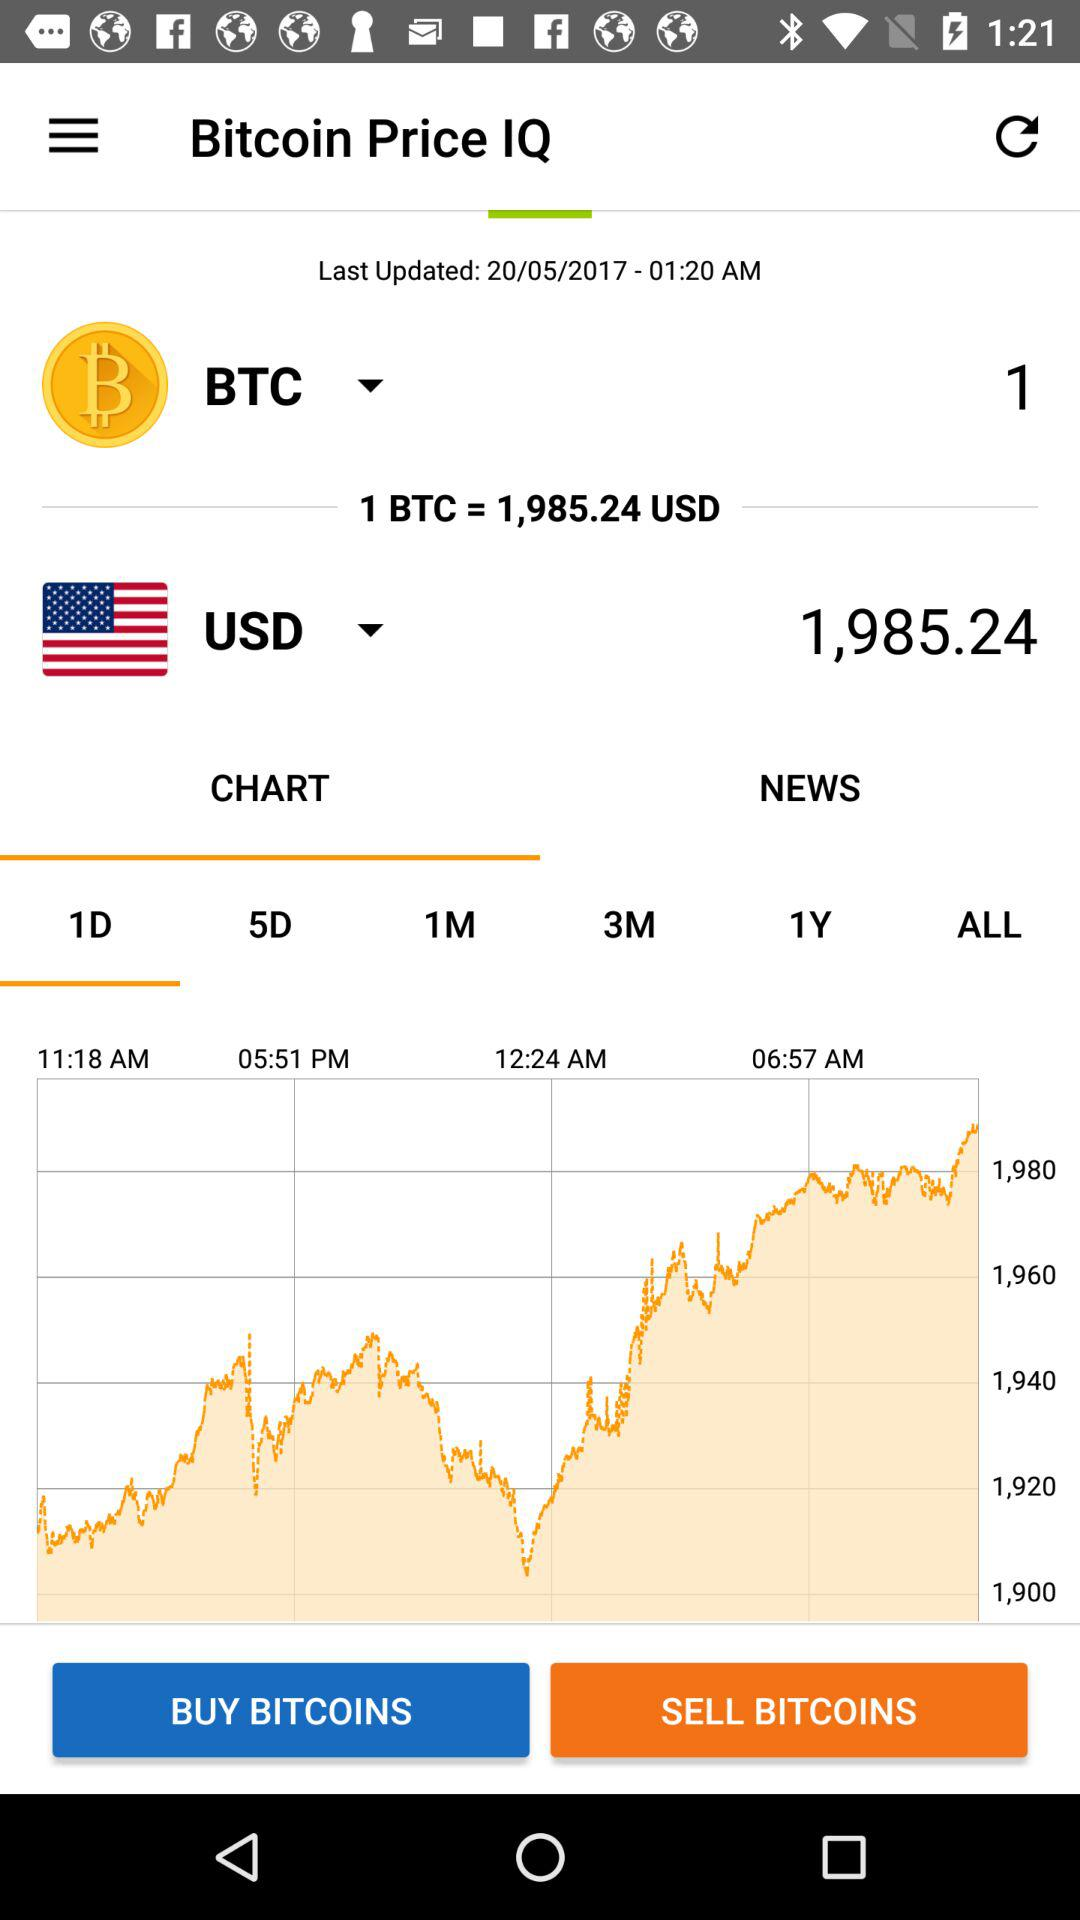When was it last updated? It was last updated on May 20, 2017 at 01:20 AM. 